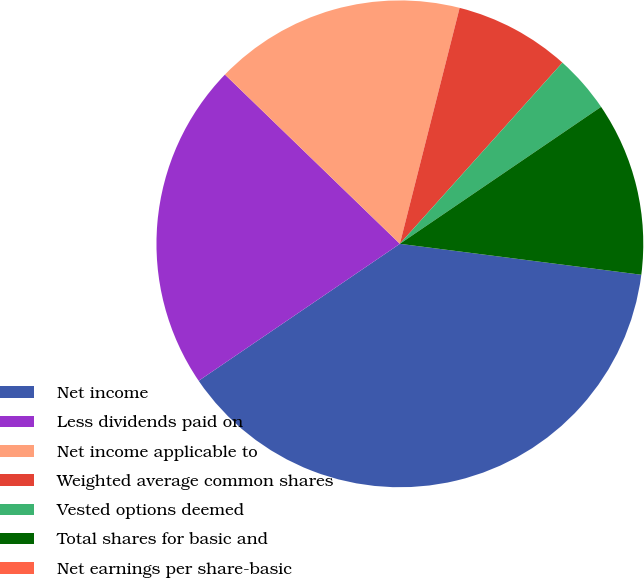Convert chart. <chart><loc_0><loc_0><loc_500><loc_500><pie_chart><fcel>Net income<fcel>Less dividends paid on<fcel>Net income applicable to<fcel>Weighted average common shares<fcel>Vested options deemed<fcel>Total shares for basic and<fcel>Net earnings per share-basic<nl><fcel>38.46%<fcel>21.75%<fcel>16.71%<fcel>7.69%<fcel>3.85%<fcel>11.54%<fcel>0.0%<nl></chart> 